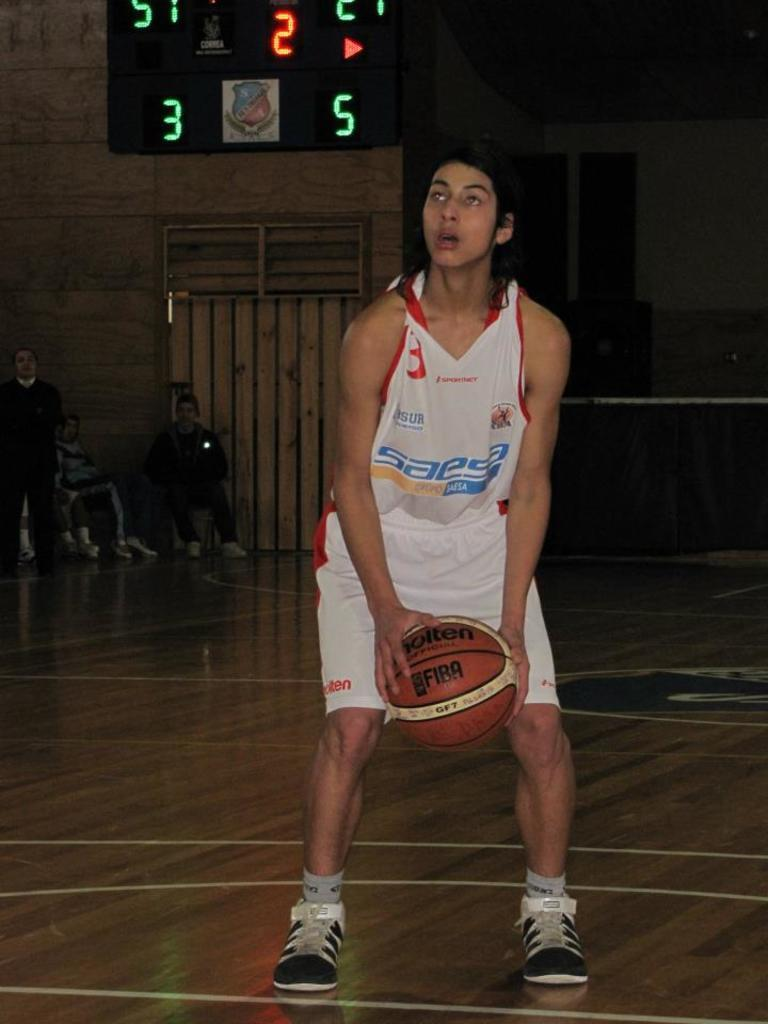Provide a one-sentence caption for the provided image. Saesa is a sponsor of the basketball team. 